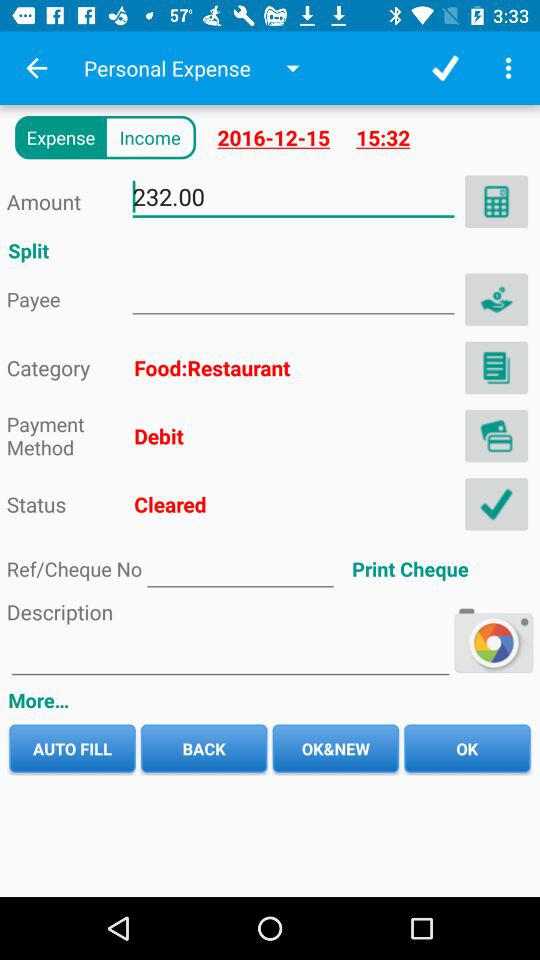What is the payment method for this expense?
Answer the question using a single word or phrase. Debit 